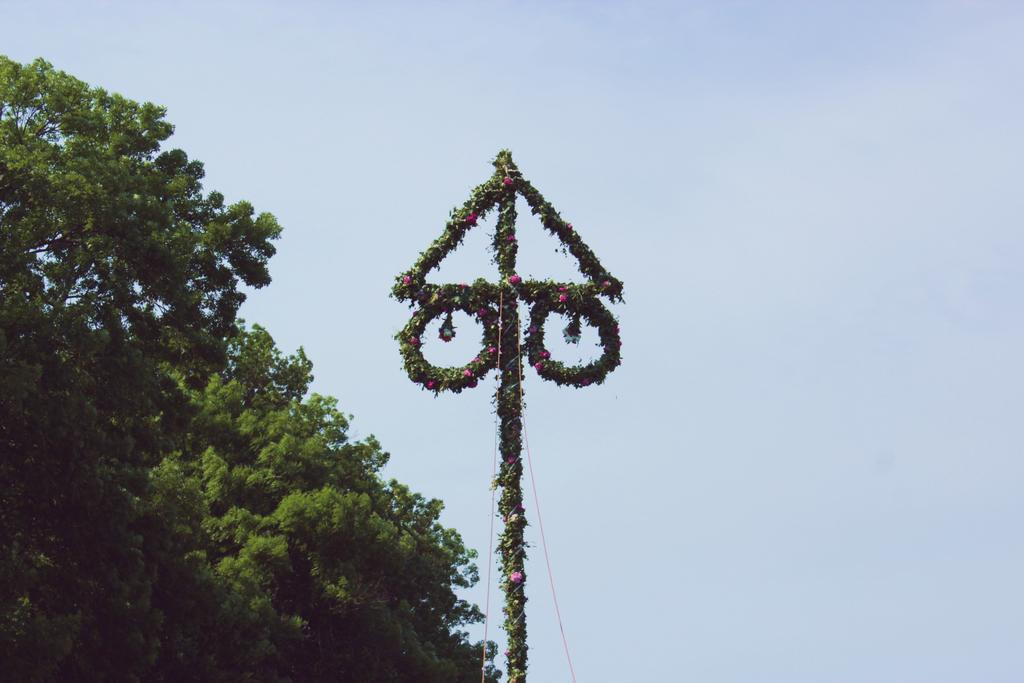What type of plant is present in the image? There is a tree in the image. What can be seen in the background of the image? The sky is visible in the image. What is the pole in the image covered with? The pole is covered with flowers and leaves in the image. What color are the objects in the image? There are red-colored objects in the objects in the image are red. How does the cart move around in the image? There is no cart present in the image. What is the back of the tree in the image? The image does not show the back of the tree, as it is a two-dimensional representation. 